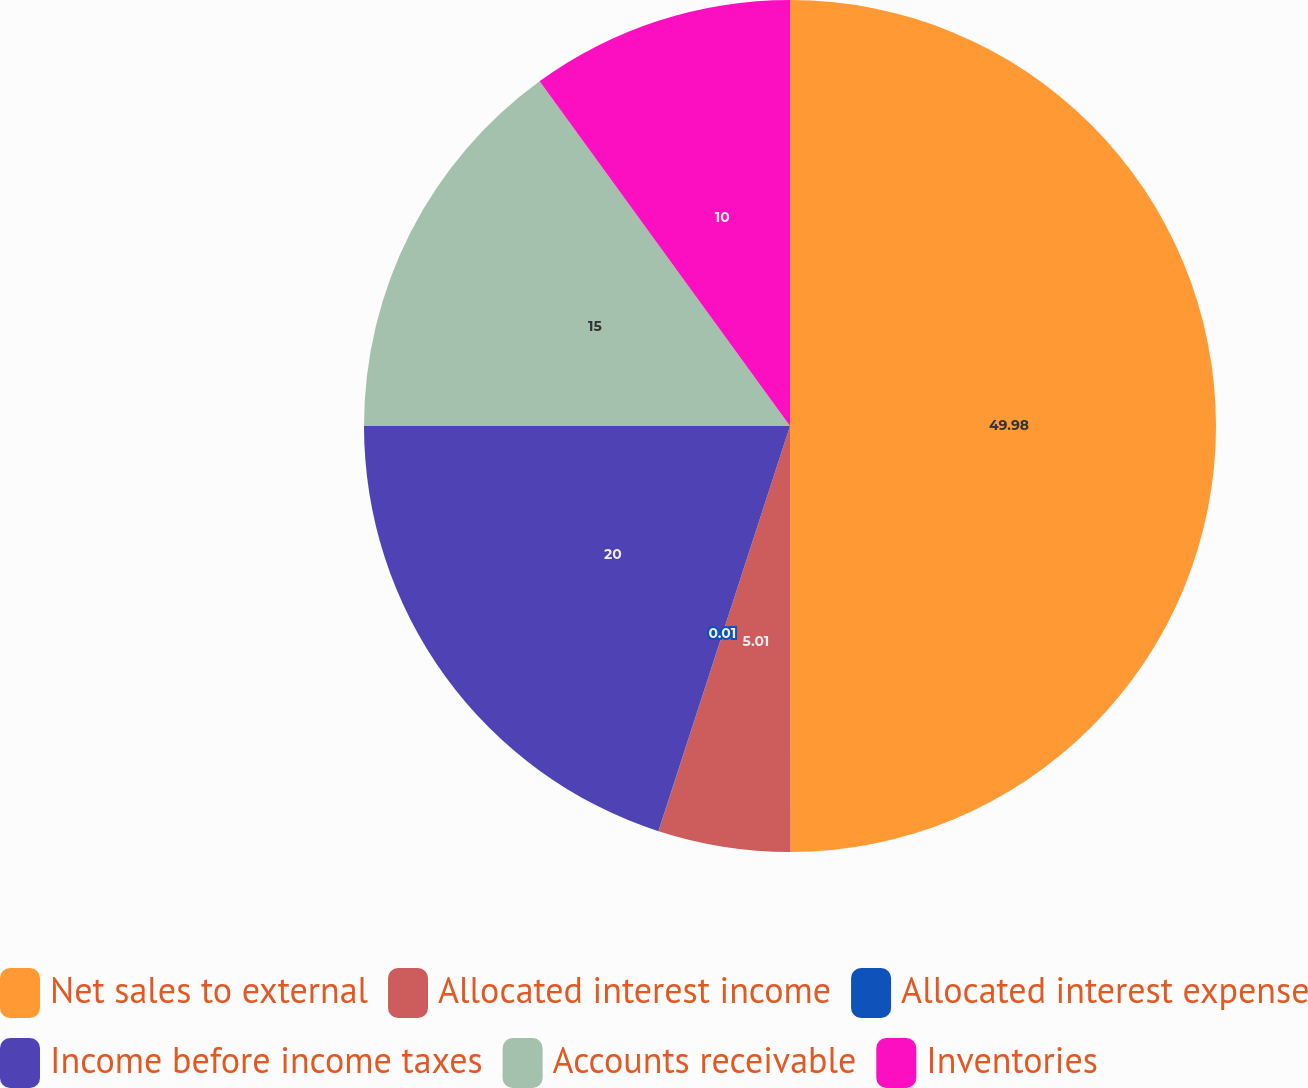Convert chart to OTSL. <chart><loc_0><loc_0><loc_500><loc_500><pie_chart><fcel>Net sales to external<fcel>Allocated interest income<fcel>Allocated interest expense<fcel>Income before income taxes<fcel>Accounts receivable<fcel>Inventories<nl><fcel>49.98%<fcel>5.01%<fcel>0.01%<fcel>20.0%<fcel>15.0%<fcel>10.0%<nl></chart> 